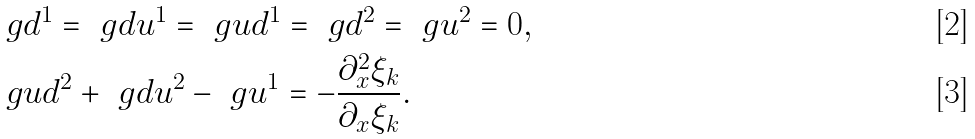<formula> <loc_0><loc_0><loc_500><loc_500>& \ g d ^ { 1 } = \ g d u ^ { 1 } = \ g u d ^ { 1 } = \ g d ^ { 2 } = \ g u ^ { 2 } = 0 , \\ & \ g u d ^ { 2 } + \ g d u ^ { 2 } - \ g u ^ { 1 } = - \frac { \partial _ { x } ^ { 2 } \xi _ { k } } { \partial _ { x } \xi _ { k } } .</formula> 